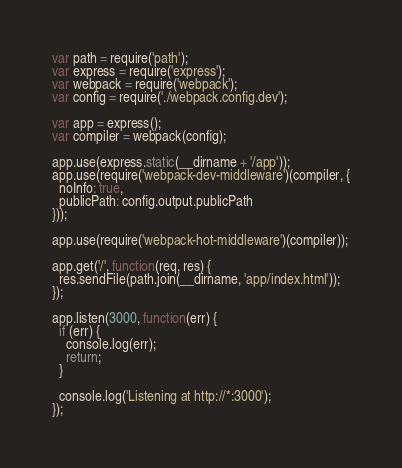<code> <loc_0><loc_0><loc_500><loc_500><_JavaScript_>var path = require('path');
var express = require('express');
var webpack = require('webpack');
var config = require('./webpack.config.dev');

var app = express();
var compiler = webpack(config);

app.use(express.static(__dirname + '/app'));
app.use(require('webpack-dev-middleware')(compiler, {
  noInfo: true,
  publicPath: config.output.publicPath
}));

app.use(require('webpack-hot-middleware')(compiler));

app.get('/', function(req, res) {
  res.sendFile(path.join(__dirname, 'app/index.html'));
});

app.listen(3000, function(err) {
  if (err) {
    console.log(err);
    return;
  }

  console.log('Listening at http://*:3000');
});
</code> 